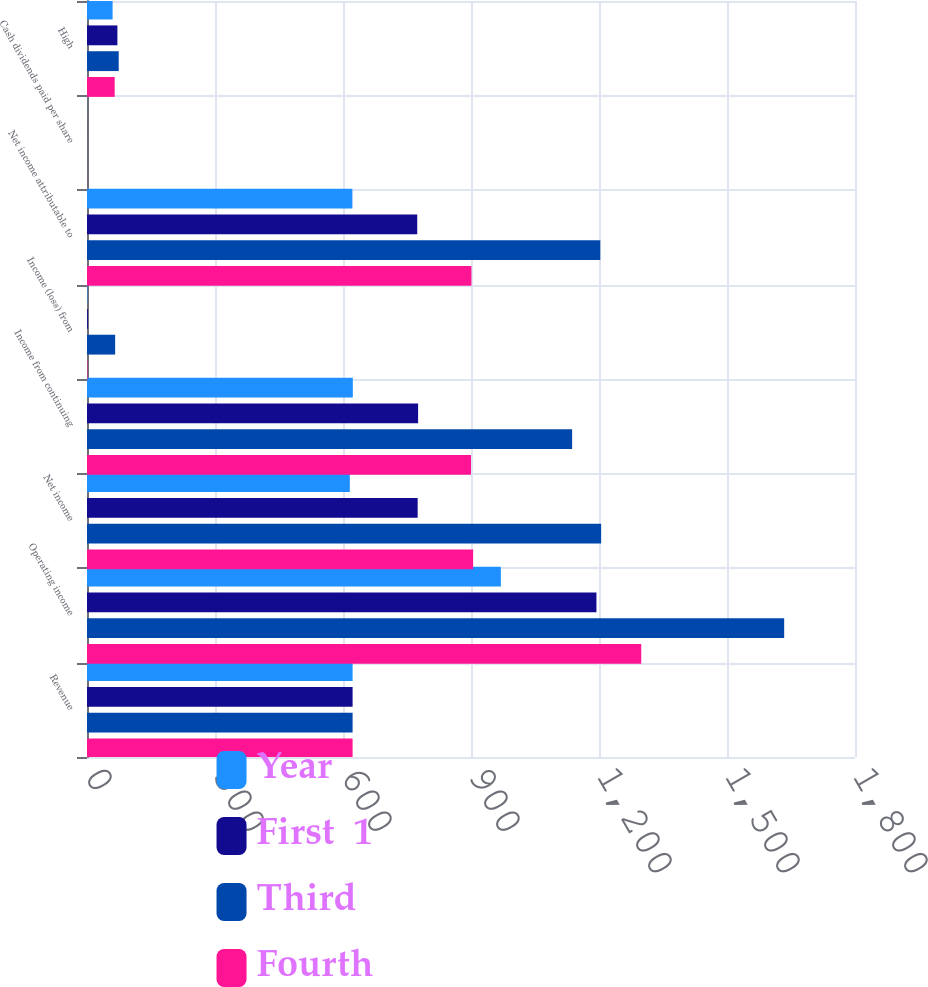Convert chart. <chart><loc_0><loc_0><loc_500><loc_500><stacked_bar_chart><ecel><fcel>Revenue<fcel>Operating income<fcel>Net income<fcel>Income from continuing<fcel>Income (loss) from<fcel>Net income attributable to<fcel>Cash dividends paid per share<fcel>High<nl><fcel>Year<fcel>622.5<fcel>970<fcel>616<fcel>623<fcel>1<fcel>622<fcel>0.15<fcel>59.99<nl><fcel>First  1<fcel>622.5<fcel>1194<fcel>775<fcel>776<fcel>2<fcel>774<fcel>0.15<fcel>71.26<nl><fcel>Third<fcel>622.5<fcel>1634<fcel>1205<fcel>1137<fcel>66<fcel>1203<fcel>0.15<fcel>74.33<nl><fcel>Fourth<fcel>622.5<fcel>1299<fcel>905<fcel>900<fcel>1<fcel>901<fcel>0.18<fcel>64.88<nl></chart> 